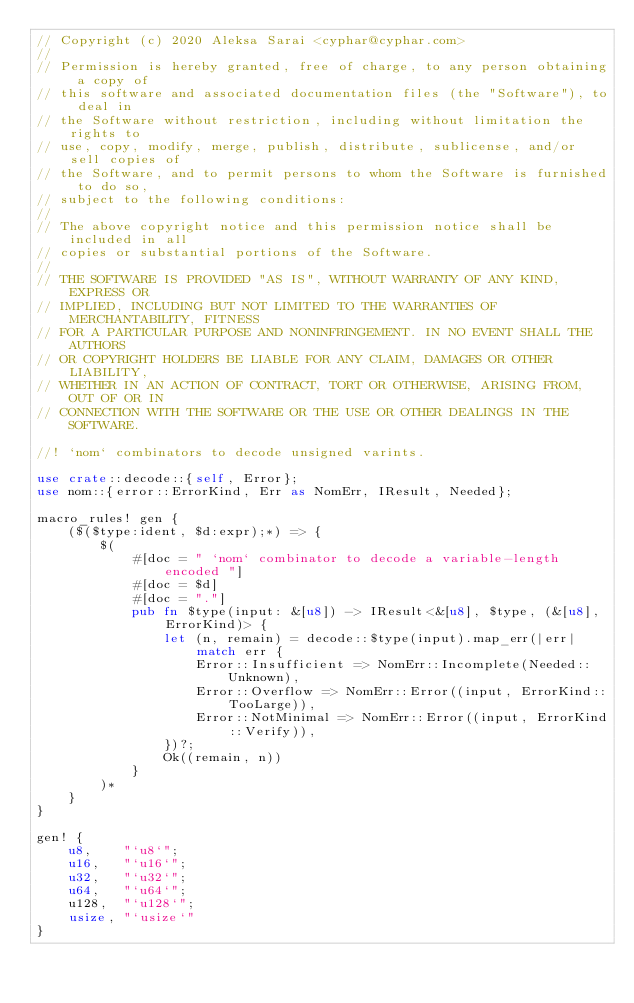Convert code to text. <code><loc_0><loc_0><loc_500><loc_500><_Rust_>// Copyright (c) 2020 Aleksa Sarai <cyphar@cyphar.com>
//
// Permission is hereby granted, free of charge, to any person obtaining a copy of
// this software and associated documentation files (the "Software"), to deal in
// the Software without restriction, including without limitation the rights to
// use, copy, modify, merge, publish, distribute, sublicense, and/or sell copies of
// the Software, and to permit persons to whom the Software is furnished to do so,
// subject to the following conditions:
//
// The above copyright notice and this permission notice shall be included in all
// copies or substantial portions of the Software.
//
// THE SOFTWARE IS PROVIDED "AS IS", WITHOUT WARRANTY OF ANY KIND, EXPRESS OR
// IMPLIED, INCLUDING BUT NOT LIMITED TO THE WARRANTIES OF MERCHANTABILITY, FITNESS
// FOR A PARTICULAR PURPOSE AND NONINFRINGEMENT. IN NO EVENT SHALL THE AUTHORS
// OR COPYRIGHT HOLDERS BE LIABLE FOR ANY CLAIM, DAMAGES OR OTHER LIABILITY,
// WHETHER IN AN ACTION OF CONTRACT, TORT OR OTHERWISE, ARISING FROM, OUT OF OR IN
// CONNECTION WITH THE SOFTWARE OR THE USE OR OTHER DEALINGS IN THE SOFTWARE.

//! `nom` combinators to decode unsigned varints.

use crate::decode::{self, Error};
use nom::{error::ErrorKind, Err as NomErr, IResult, Needed};

macro_rules! gen {
    ($($type:ident, $d:expr);*) => {
        $(
            #[doc = " `nom` combinator to decode a variable-length encoded "]
            #[doc = $d]
            #[doc = "."]
            pub fn $type(input: &[u8]) -> IResult<&[u8], $type, (&[u8], ErrorKind)> {
                let (n, remain) = decode::$type(input).map_err(|err| match err {
                    Error::Insufficient => NomErr::Incomplete(Needed::Unknown),
                    Error::Overflow => NomErr::Error((input, ErrorKind::TooLarge)),
                    Error::NotMinimal => NomErr::Error((input, ErrorKind::Verify)),
                })?;
                Ok((remain, n))
            }
        )*
    }
}

gen! {
    u8,    "`u8`";
    u16,   "`u16`";
    u32,   "`u32`";
    u64,   "`u64`";
    u128,  "`u128`";
    usize, "`usize`"
}
</code> 